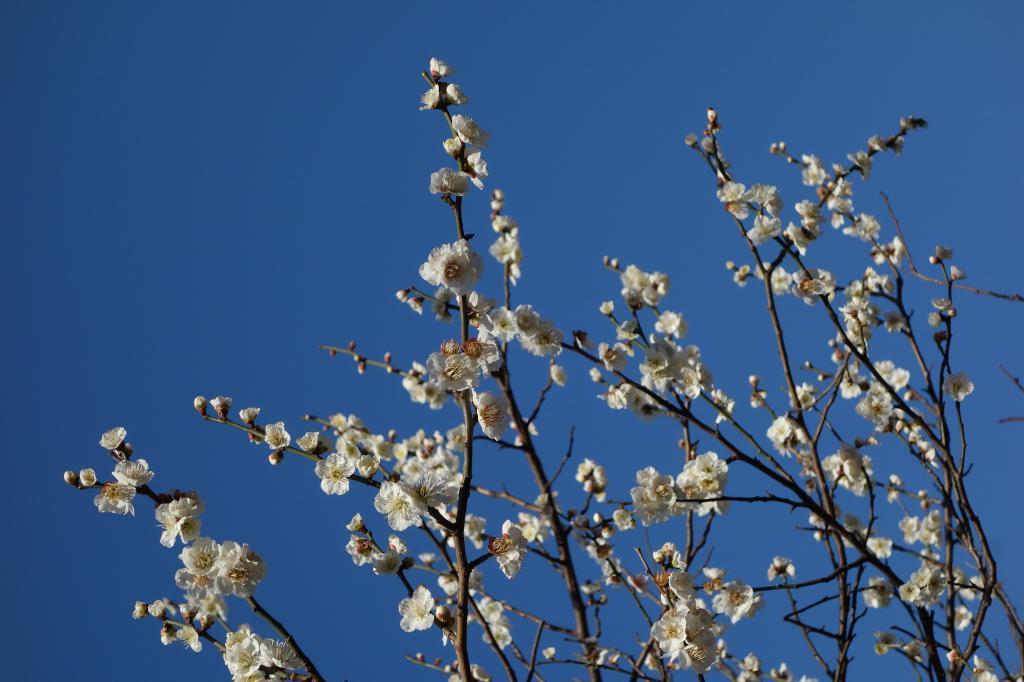In one or two sentences, can you explain what this image depicts? Here there is a tree, this is blue color sky. 